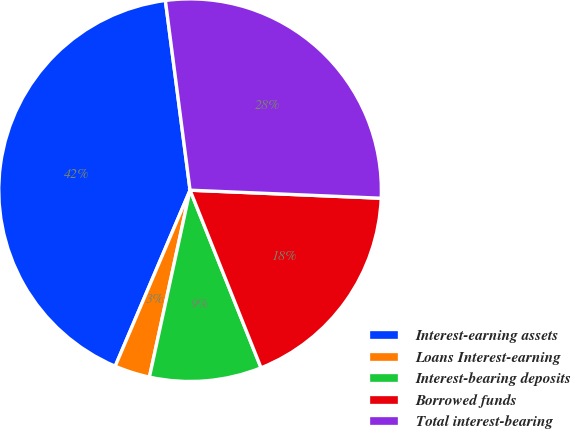<chart> <loc_0><loc_0><loc_500><loc_500><pie_chart><fcel>Interest-earning assets<fcel>Loans Interest-earning<fcel>Interest-bearing deposits<fcel>Borrowed funds<fcel>Total interest-bearing<nl><fcel>41.54%<fcel>2.99%<fcel>9.46%<fcel>18.28%<fcel>27.73%<nl></chart> 